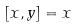<formula> <loc_0><loc_0><loc_500><loc_500>[ x , y ] = x</formula> 